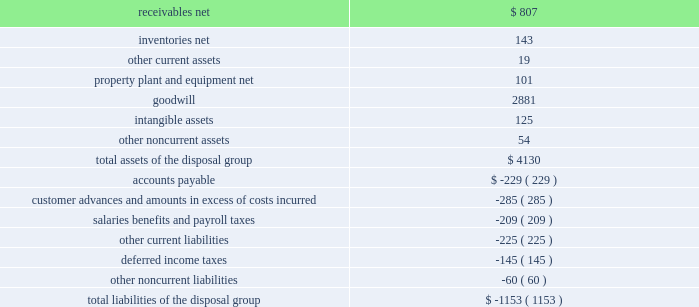Divestiture of the information systems & global solutions business on august 16 , 2016 , we completed the previously announced divestiture of the is&gs business , which merged with a subsidiary of leidos , in a reverse morris trust transaction ( the 201ctransaction 201d ) .
The transaction was completed in a multi- step process pursuant to which we initially contributed the is&gs business to abacus innovations corporation ( abacus ) , a wholly owned subsidiary of lockheed martin created to facilitate the transaction , and the common stock of abacus was distributed to participating lockheed martin stockholders through an exchange offer .
Under the terms of the exchange offer , lockheed martin stockholders had the option to exchange shares of lockheed martin common stock for shares of abacus common stock .
At the conclusion of the exchange offer , all shares of abacus common stock were exchanged for 9369694 shares of lockheed martin common stock held by lockheed martin stockholders that elected to participate in the exchange .
The shares of lockheed martin common stock that were exchanged and accepted were retired , reducing the number of shares of our common stock outstanding by approximately 3% ( 3 % ) .
Following the exchange offer , abacus merged with a subsidiary of leidos , with abacus continuing as the surviving corporation and a wholly-owned subsidiary of leidos .
As part of the merger , each share of abacus common stock was automatically converted into one share of leidos common stock .
We did not receive any shares of leidos common stock as part of the transaction and do not hold any shares of leidos or abacus common stock following the transaction .
Based on an opinion of outside tax counsel , subject to customary qualifications and based on factual representations , the exchange offer and merger will qualify as tax-free transactions to lockheed martin and its stockholders , except to the extent that cash was paid to lockheed martin stockholders in lieu of fractional shares .
In connection with the transaction , abacus borrowed an aggregate principal amount of approximately $ 1.84 billion under term loan facilities with third party financial institutions , the proceeds of which were used to make a one-time special cash payment of $ 1.80 billion to lockheed martin and to pay associated borrowing fees and expenses .
The entire special cash payment was used to repay debt , pay dividends and repurchase stock during the third and fourth quarters of 2016 .
The obligations under the abacus term loan facilities were guaranteed by leidos as part of the transaction .
As a result of the transaction , we recognized a net gain of approximately $ 1.2 billion .
The net gain represents the $ 2.5 billion fair value of the shares of lockheed martin common stock exchanged and retired as part of the exchange offer , plus the $ 1.8 billion one-time special cash payment , less the net book value of the is&gs business of about $ 3.0 billion at august 16 , 2016 and other adjustments of about $ 100 million .
The final gain is subject to certain post-closing adjustments , including final working capital , indemnification , and tax adjustments , which we expect to complete in 2017 .
We classified the operating results of our is&gs business as discontinued operations in our consolidated financial statements in accordance with u.s .
Gaap , as the divestiture of this business represented a strategic shift that had a major effect on our operations and financial results .
However , the cash flows generated by the is&gs business have not been reclassified in our consolidated statements of cash flows as we retained this cash as part of the transaction .
The carrying amounts of major classes of the is&gs business assets and liabilities that were classified as assets and liabilities of discontinued operations as of december 31 , 2015 are as follows ( in millions ) : .

What percentage of the total assets of the disposal group were attributable to goodwill? 
Computations: (2881 / 4130)
Answer: 0.69758. 